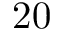Convert formula to latex. <formula><loc_0><loc_0><loc_500><loc_500>2 0</formula> 